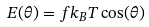<formula> <loc_0><loc_0><loc_500><loc_500>E ( \theta ) = f k _ { B } T \cos ( \theta )</formula> 